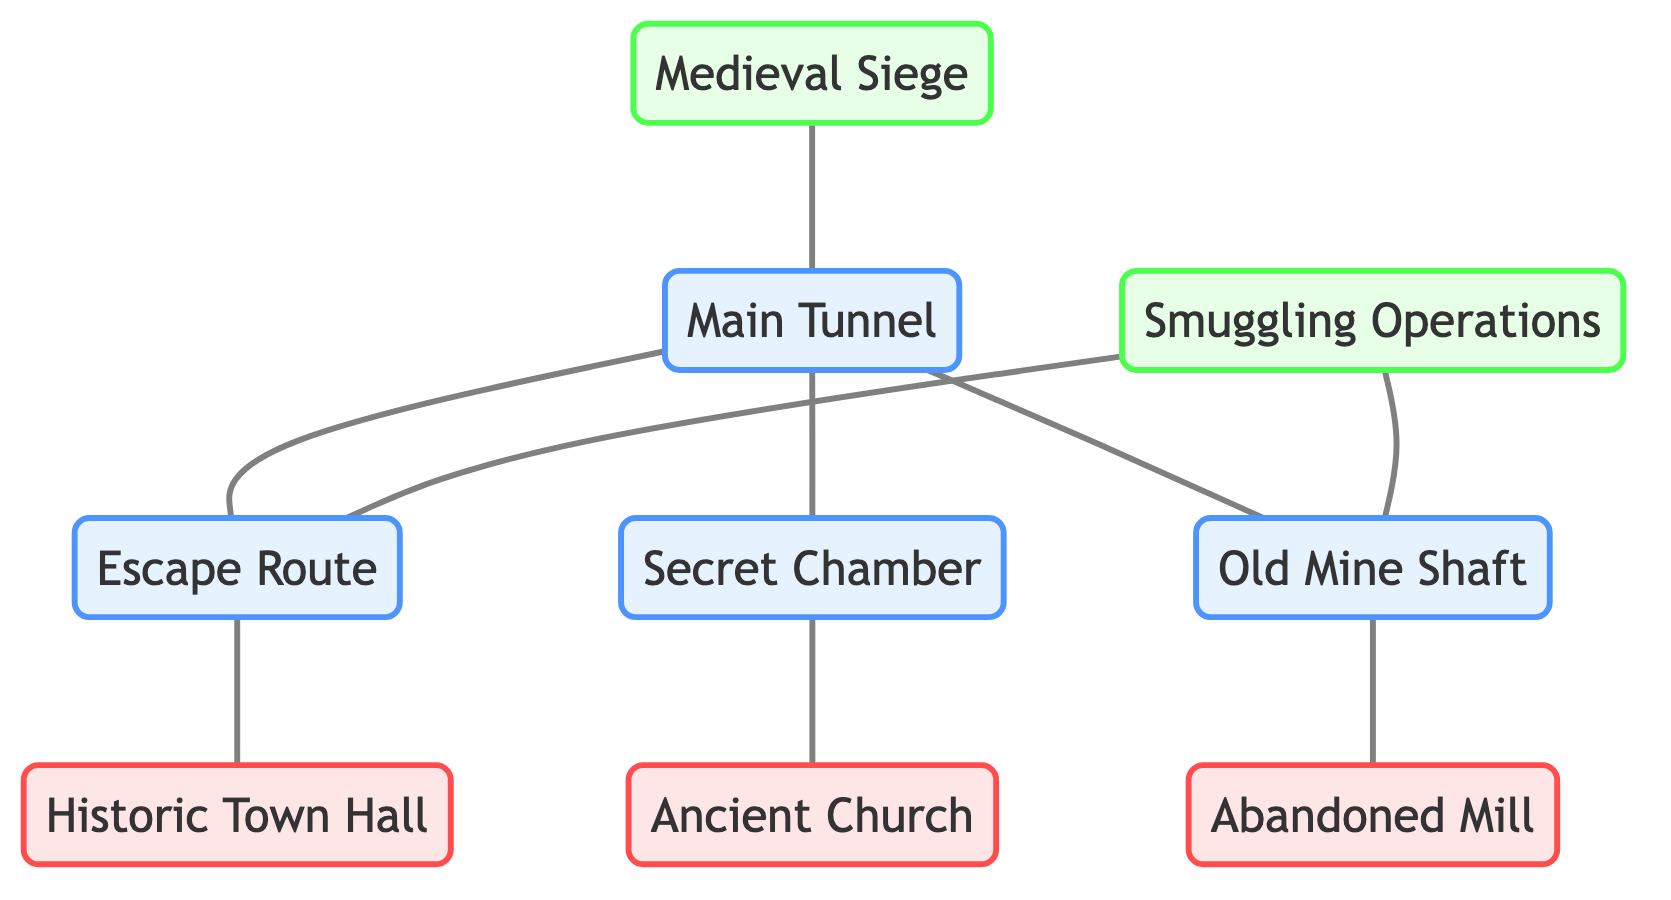What is the total number of nodes in the diagram? The diagram consists of a collection of nodes, and by counting them, we find there are eight distinct nodes: four tunnels, three landmarks, and two events.
Answer: 8 Which landmark is connected to the Secret Chamber? By examining the connections from the Secret Chamber node, we see there is a direct edge linking it to the Ancient Church.
Answer: Ancient Church How many tunnels are directly connected to the Main Tunnel? The Main Tunnel is connected to three other nodes: the Escape Route, Secret Chamber, and Old Mine Shaft. Thus, the total count of tunnels connected to the Main Tunnel is three.
Answer: 3 What event is associated with the Escape Route? Looking at the relationships, the Escape Route is connected to the Smuggling Operations event, indicating its historical relevance to this event.
Answer: Smuggling Operations Which tunnel connects to the Abandoned Mill? The Old Mine Shaft node is directly linked to the Abandoned Mill, showing that this tunnel leads towards the mill in terms of the diagram structure.
Answer: Old Mine Shaft How many edges are there in total in the diagram? By counting the connections shown in the edges section, we find there are nine edges in total, connecting various nodes in the diagram.
Answer: 9 What two events are represented in the diagram? The two events present in the diagram are the Medieval Siege and Smuggling Operations, as highlighted in the events' nodes.
Answer: Medieval Siege, Smuggling Operations Which tunnel is linked to both events shown in the graph? The Smuggling Operations event is linked to two tunnels, specifically the Escape Route and the Old Mine Shaft, demonstrating its connection to multiple routes.
Answer: Escape Route, Old Mine Shaft 